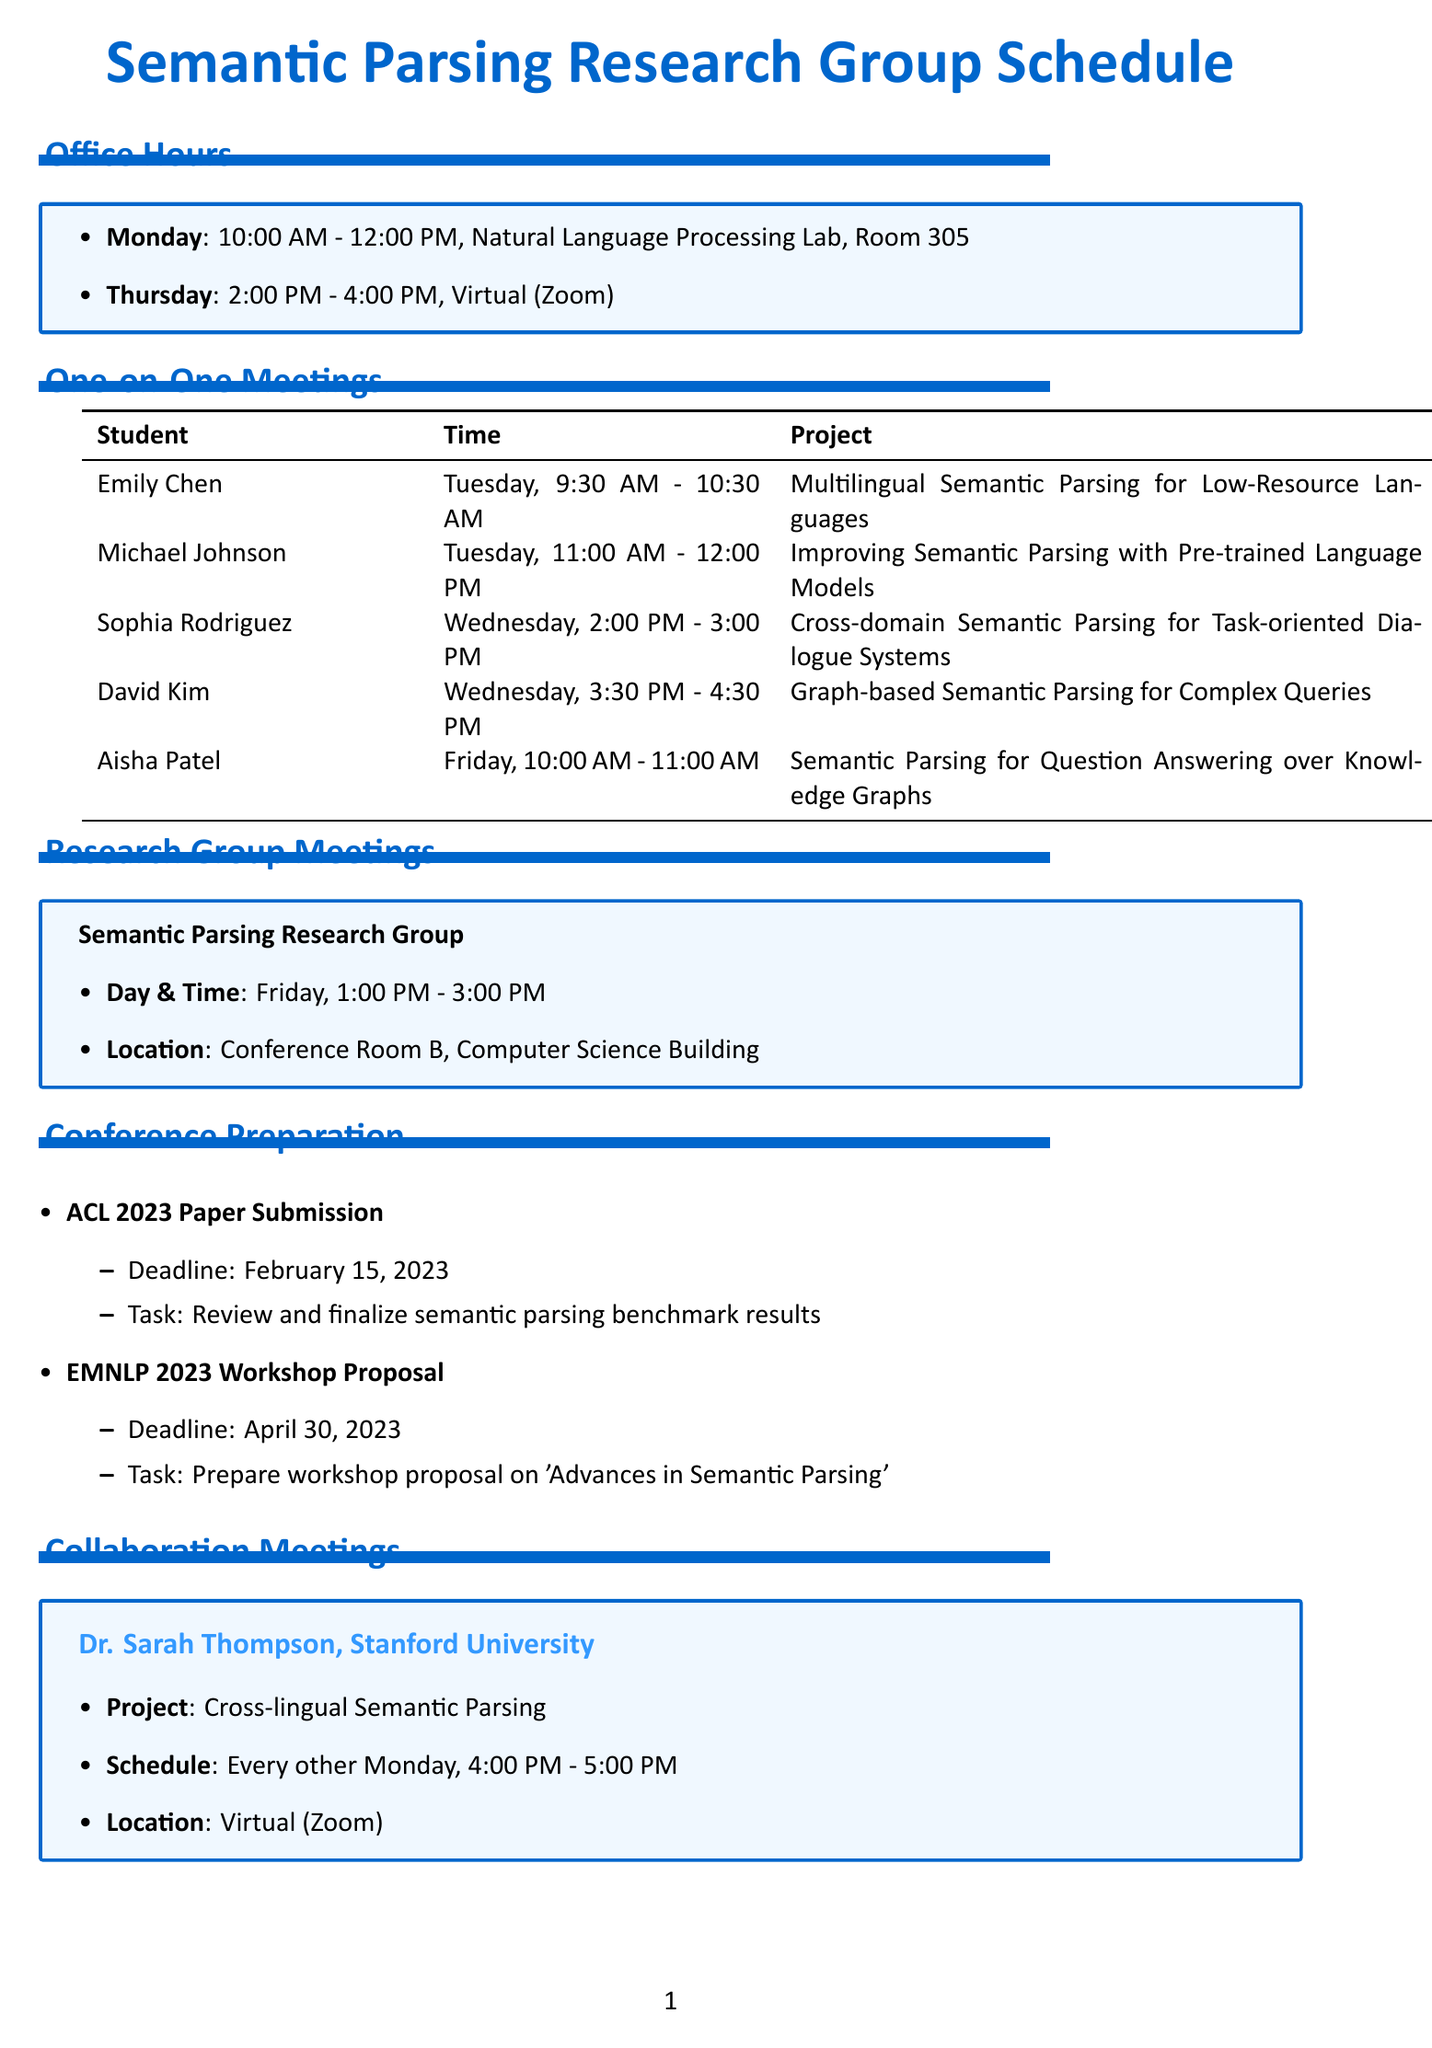What day and time are office hours on Monday? The document states that office hours on Monday are from 10:00 AM to 12:00 PM.
Answer: Monday, 10:00 AM - 12:00 PM Who is scheduled for a one-on-one meeting at 11:00 AM on Tuesday? The schedule lists Michael Johnson for a one-on-one meeting at this time.
Answer: Michael Johnson What is the location of the research group meetings? According to the document, the location is Conference Room B, Computer Science Building.
Answer: Conference Room B, Computer Science Building How many graduate students are meeting on Wednesday? The document indicates two students, Sophia Rodriguez and David Kim, have meetings on Wednesday.
Answer: Two What project is Aisha Patel working on? Aisha Patel's project is described as Semantic Parsing for Question Answering over Knowledge Graphs.
Answer: Semantic Parsing for Question Answering over Knowledge Graphs On which day do collaboration meetings with Dr. Sarah Thompson occur? The document specifies that collaboration meetings with Dr. Sarah Thompson happen every other Monday.
Answer: Every other Monday When is the deadline for the ACL 2023 Paper Submission? The document mentions the deadline for this task is February 15, 2023.
Answer: February 15, 2023 What time is the research group meeting on Friday? The document states that the research group meeting is from 1:00 PM to 3:00 PM on Friday.
Answer: 1:00 PM - 3:00 PM 